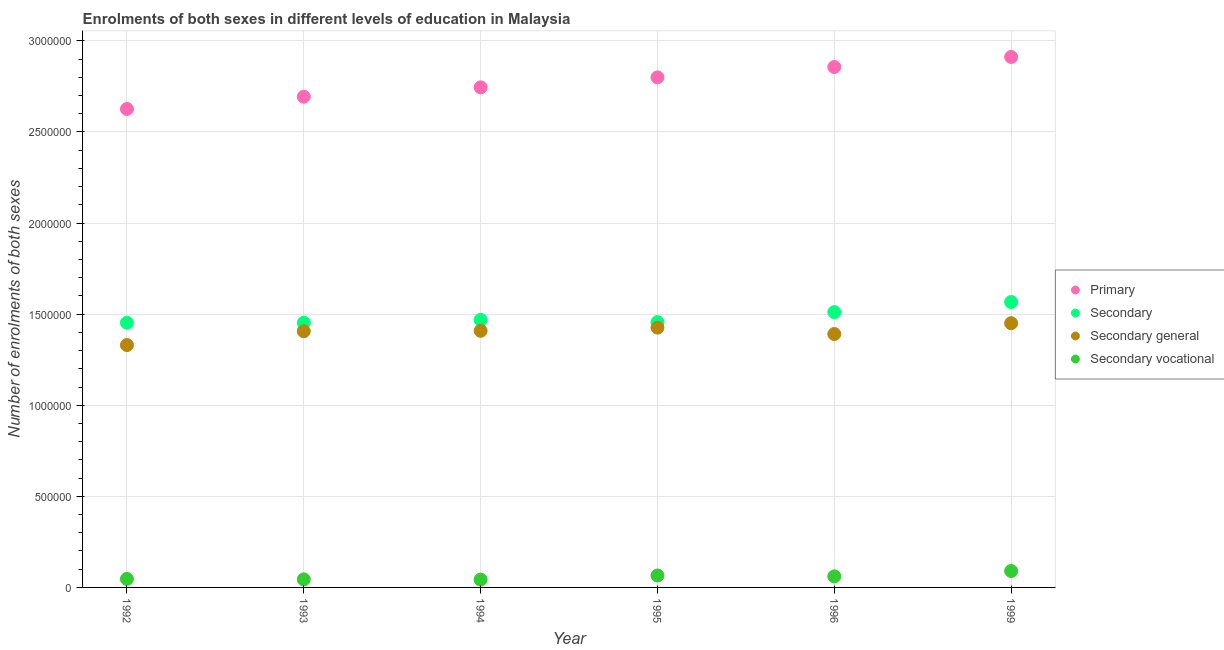Is the number of dotlines equal to the number of legend labels?
Make the answer very short. Yes. What is the number of enrolments in secondary vocational education in 1994?
Your response must be concise. 4.29e+04. Across all years, what is the maximum number of enrolments in primary education?
Make the answer very short. 2.91e+06. Across all years, what is the minimum number of enrolments in secondary general education?
Provide a short and direct response. 1.33e+06. In which year was the number of enrolments in primary education maximum?
Provide a succinct answer. 1999. What is the total number of enrolments in secondary vocational education in the graph?
Provide a succinct answer. 3.50e+05. What is the difference between the number of enrolments in primary education in 1994 and that in 1996?
Make the answer very short. -1.12e+05. What is the difference between the number of enrolments in secondary general education in 1994 and the number of enrolments in secondary vocational education in 1992?
Give a very brief answer. 1.36e+06. What is the average number of enrolments in secondary education per year?
Give a very brief answer. 1.48e+06. In the year 1999, what is the difference between the number of enrolments in secondary vocational education and number of enrolments in secondary education?
Keep it short and to the point. -1.48e+06. In how many years, is the number of enrolments in secondary education greater than 1600000?
Your answer should be very brief. 0. What is the ratio of the number of enrolments in secondary vocational education in 1992 to that in 1999?
Provide a succinct answer. 0.52. Is the number of enrolments in secondary general education in 1992 less than that in 1995?
Your answer should be very brief. Yes. Is the difference between the number of enrolments in secondary general education in 1992 and 1996 greater than the difference between the number of enrolments in secondary vocational education in 1992 and 1996?
Your answer should be compact. No. What is the difference between the highest and the second highest number of enrolments in primary education?
Offer a very short reply. 5.52e+04. What is the difference between the highest and the lowest number of enrolments in primary education?
Give a very brief answer. 2.85e+05. Is it the case that in every year, the sum of the number of enrolments in primary education and number of enrolments in secondary education is greater than the number of enrolments in secondary general education?
Your answer should be compact. Yes. What is the difference between two consecutive major ticks on the Y-axis?
Keep it short and to the point. 5.00e+05. Are the values on the major ticks of Y-axis written in scientific E-notation?
Keep it short and to the point. No. Does the graph contain grids?
Offer a terse response. Yes. What is the title of the graph?
Your response must be concise. Enrolments of both sexes in different levels of education in Malaysia. What is the label or title of the X-axis?
Make the answer very short. Year. What is the label or title of the Y-axis?
Offer a terse response. Number of enrolments of both sexes. What is the Number of enrolments of both sexes of Primary in 1992?
Offer a very short reply. 2.63e+06. What is the Number of enrolments of both sexes of Secondary in 1992?
Ensure brevity in your answer.  1.45e+06. What is the Number of enrolments of both sexes of Secondary general in 1992?
Provide a succinct answer. 1.33e+06. What is the Number of enrolments of both sexes in Secondary vocational in 1992?
Ensure brevity in your answer.  4.67e+04. What is the Number of enrolments of both sexes in Primary in 1993?
Your answer should be very brief. 2.69e+06. What is the Number of enrolments of both sexes in Secondary in 1993?
Provide a short and direct response. 1.45e+06. What is the Number of enrolments of both sexes of Secondary general in 1993?
Offer a terse response. 1.41e+06. What is the Number of enrolments of both sexes in Secondary vocational in 1993?
Keep it short and to the point. 4.43e+04. What is the Number of enrolments of both sexes in Primary in 1994?
Your response must be concise. 2.74e+06. What is the Number of enrolments of both sexes in Secondary in 1994?
Your answer should be compact. 1.47e+06. What is the Number of enrolments of both sexes in Secondary general in 1994?
Your response must be concise. 1.41e+06. What is the Number of enrolments of both sexes in Secondary vocational in 1994?
Give a very brief answer. 4.29e+04. What is the Number of enrolments of both sexes in Primary in 1995?
Give a very brief answer. 2.80e+06. What is the Number of enrolments of both sexes of Secondary in 1995?
Give a very brief answer. 1.46e+06. What is the Number of enrolments of both sexes in Secondary general in 1995?
Your answer should be very brief. 1.43e+06. What is the Number of enrolments of both sexes of Secondary vocational in 1995?
Your response must be concise. 6.55e+04. What is the Number of enrolments of both sexes of Primary in 1996?
Offer a very short reply. 2.86e+06. What is the Number of enrolments of both sexes of Secondary in 1996?
Give a very brief answer. 1.51e+06. What is the Number of enrolments of both sexes of Secondary general in 1996?
Ensure brevity in your answer.  1.39e+06. What is the Number of enrolments of both sexes in Secondary vocational in 1996?
Keep it short and to the point. 6.08e+04. What is the Number of enrolments of both sexes of Primary in 1999?
Make the answer very short. 2.91e+06. What is the Number of enrolments of both sexes of Secondary in 1999?
Provide a short and direct response. 1.57e+06. What is the Number of enrolments of both sexes of Secondary general in 1999?
Provide a short and direct response. 1.45e+06. What is the Number of enrolments of both sexes in Secondary vocational in 1999?
Provide a succinct answer. 9.01e+04. Across all years, what is the maximum Number of enrolments of both sexes of Primary?
Your response must be concise. 2.91e+06. Across all years, what is the maximum Number of enrolments of both sexes of Secondary?
Ensure brevity in your answer.  1.57e+06. Across all years, what is the maximum Number of enrolments of both sexes in Secondary general?
Provide a succinct answer. 1.45e+06. Across all years, what is the maximum Number of enrolments of both sexes in Secondary vocational?
Keep it short and to the point. 9.01e+04. Across all years, what is the minimum Number of enrolments of both sexes in Primary?
Provide a succinct answer. 2.63e+06. Across all years, what is the minimum Number of enrolments of both sexes in Secondary?
Ensure brevity in your answer.  1.45e+06. Across all years, what is the minimum Number of enrolments of both sexes of Secondary general?
Your answer should be compact. 1.33e+06. Across all years, what is the minimum Number of enrolments of both sexes of Secondary vocational?
Give a very brief answer. 4.29e+04. What is the total Number of enrolments of both sexes in Primary in the graph?
Provide a short and direct response. 1.66e+07. What is the total Number of enrolments of both sexes of Secondary in the graph?
Make the answer very short. 8.91e+06. What is the total Number of enrolments of both sexes of Secondary general in the graph?
Ensure brevity in your answer.  8.41e+06. What is the total Number of enrolments of both sexes in Secondary vocational in the graph?
Offer a terse response. 3.50e+05. What is the difference between the Number of enrolments of both sexes of Primary in 1992 and that in 1993?
Ensure brevity in your answer.  -6.73e+04. What is the difference between the Number of enrolments of both sexes in Secondary in 1992 and that in 1993?
Provide a succinct answer. -42. What is the difference between the Number of enrolments of both sexes of Secondary general in 1992 and that in 1993?
Your response must be concise. -7.59e+04. What is the difference between the Number of enrolments of both sexes of Secondary vocational in 1992 and that in 1993?
Your response must be concise. 2404. What is the difference between the Number of enrolments of both sexes of Primary in 1992 and that in 1994?
Make the answer very short. -1.19e+05. What is the difference between the Number of enrolments of both sexes in Secondary in 1992 and that in 1994?
Your answer should be compact. -1.59e+04. What is the difference between the Number of enrolments of both sexes of Secondary general in 1992 and that in 1994?
Provide a succinct answer. -7.83e+04. What is the difference between the Number of enrolments of both sexes of Secondary vocational in 1992 and that in 1994?
Make the answer very short. 3797. What is the difference between the Number of enrolments of both sexes in Primary in 1992 and that in 1995?
Make the answer very short. -1.73e+05. What is the difference between the Number of enrolments of both sexes in Secondary in 1992 and that in 1995?
Keep it short and to the point. -3573. What is the difference between the Number of enrolments of both sexes of Secondary general in 1992 and that in 1995?
Your answer should be compact. -9.56e+04. What is the difference between the Number of enrolments of both sexes in Secondary vocational in 1992 and that in 1995?
Provide a short and direct response. -1.88e+04. What is the difference between the Number of enrolments of both sexes in Primary in 1992 and that in 1996?
Your answer should be compact. -2.30e+05. What is the difference between the Number of enrolments of both sexes of Secondary in 1992 and that in 1996?
Your answer should be very brief. -5.82e+04. What is the difference between the Number of enrolments of both sexes in Secondary general in 1992 and that in 1996?
Offer a terse response. -6.07e+04. What is the difference between the Number of enrolments of both sexes in Secondary vocational in 1992 and that in 1996?
Your answer should be compact. -1.41e+04. What is the difference between the Number of enrolments of both sexes of Primary in 1992 and that in 1999?
Provide a short and direct response. -2.85e+05. What is the difference between the Number of enrolments of both sexes in Secondary in 1992 and that in 1999?
Provide a short and direct response. -1.14e+05. What is the difference between the Number of enrolments of both sexes of Secondary general in 1992 and that in 1999?
Your response must be concise. -1.20e+05. What is the difference between the Number of enrolments of both sexes of Secondary vocational in 1992 and that in 1999?
Provide a succinct answer. -4.34e+04. What is the difference between the Number of enrolments of both sexes in Primary in 1993 and that in 1994?
Provide a short and direct response. -5.14e+04. What is the difference between the Number of enrolments of both sexes of Secondary in 1993 and that in 1994?
Keep it short and to the point. -1.59e+04. What is the difference between the Number of enrolments of both sexes in Secondary general in 1993 and that in 1994?
Provide a succinct answer. -2446. What is the difference between the Number of enrolments of both sexes in Secondary vocational in 1993 and that in 1994?
Make the answer very short. 1393. What is the difference between the Number of enrolments of both sexes in Primary in 1993 and that in 1995?
Make the answer very short. -1.06e+05. What is the difference between the Number of enrolments of both sexes of Secondary in 1993 and that in 1995?
Provide a succinct answer. -3531. What is the difference between the Number of enrolments of both sexes of Secondary general in 1993 and that in 1995?
Your answer should be compact. -1.97e+04. What is the difference between the Number of enrolments of both sexes in Secondary vocational in 1993 and that in 1995?
Make the answer very short. -2.12e+04. What is the difference between the Number of enrolments of both sexes in Primary in 1993 and that in 1996?
Offer a terse response. -1.63e+05. What is the difference between the Number of enrolments of both sexes of Secondary in 1993 and that in 1996?
Offer a very short reply. -5.81e+04. What is the difference between the Number of enrolments of both sexes in Secondary general in 1993 and that in 1996?
Keep it short and to the point. 1.52e+04. What is the difference between the Number of enrolments of both sexes of Secondary vocational in 1993 and that in 1996?
Make the answer very short. -1.65e+04. What is the difference between the Number of enrolments of both sexes of Primary in 1993 and that in 1999?
Provide a succinct answer. -2.18e+05. What is the difference between the Number of enrolments of both sexes in Secondary in 1993 and that in 1999?
Provide a succinct answer. -1.14e+05. What is the difference between the Number of enrolments of both sexes in Secondary general in 1993 and that in 1999?
Your answer should be compact. -4.41e+04. What is the difference between the Number of enrolments of both sexes of Secondary vocational in 1993 and that in 1999?
Give a very brief answer. -4.58e+04. What is the difference between the Number of enrolments of both sexes of Primary in 1994 and that in 1995?
Your answer should be compact. -5.48e+04. What is the difference between the Number of enrolments of both sexes of Secondary in 1994 and that in 1995?
Your answer should be compact. 1.23e+04. What is the difference between the Number of enrolments of both sexes in Secondary general in 1994 and that in 1995?
Offer a very short reply. -1.73e+04. What is the difference between the Number of enrolments of both sexes in Secondary vocational in 1994 and that in 1995?
Your response must be concise. -2.26e+04. What is the difference between the Number of enrolments of both sexes in Primary in 1994 and that in 1996?
Your response must be concise. -1.12e+05. What is the difference between the Number of enrolments of both sexes in Secondary in 1994 and that in 1996?
Offer a terse response. -4.23e+04. What is the difference between the Number of enrolments of both sexes of Secondary general in 1994 and that in 1996?
Offer a very short reply. 1.76e+04. What is the difference between the Number of enrolments of both sexes of Secondary vocational in 1994 and that in 1996?
Provide a succinct answer. -1.79e+04. What is the difference between the Number of enrolments of both sexes of Primary in 1994 and that in 1999?
Keep it short and to the point. -1.67e+05. What is the difference between the Number of enrolments of both sexes in Secondary in 1994 and that in 1999?
Provide a short and direct response. -9.80e+04. What is the difference between the Number of enrolments of both sexes of Secondary general in 1994 and that in 1999?
Offer a terse response. -4.16e+04. What is the difference between the Number of enrolments of both sexes of Secondary vocational in 1994 and that in 1999?
Offer a very short reply. -4.72e+04. What is the difference between the Number of enrolments of both sexes in Primary in 1995 and that in 1996?
Offer a very short reply. -5.69e+04. What is the difference between the Number of enrolments of both sexes in Secondary in 1995 and that in 1996?
Keep it short and to the point. -5.46e+04. What is the difference between the Number of enrolments of both sexes in Secondary general in 1995 and that in 1996?
Ensure brevity in your answer.  3.49e+04. What is the difference between the Number of enrolments of both sexes of Secondary vocational in 1995 and that in 1996?
Ensure brevity in your answer.  4687. What is the difference between the Number of enrolments of both sexes of Primary in 1995 and that in 1999?
Ensure brevity in your answer.  -1.12e+05. What is the difference between the Number of enrolments of both sexes of Secondary in 1995 and that in 1999?
Offer a terse response. -1.10e+05. What is the difference between the Number of enrolments of both sexes in Secondary general in 1995 and that in 1999?
Ensure brevity in your answer.  -2.44e+04. What is the difference between the Number of enrolments of both sexes in Secondary vocational in 1995 and that in 1999?
Keep it short and to the point. -2.46e+04. What is the difference between the Number of enrolments of both sexes in Primary in 1996 and that in 1999?
Ensure brevity in your answer.  -5.52e+04. What is the difference between the Number of enrolments of both sexes in Secondary in 1996 and that in 1999?
Your response must be concise. -5.57e+04. What is the difference between the Number of enrolments of both sexes of Secondary general in 1996 and that in 1999?
Your answer should be very brief. -5.93e+04. What is the difference between the Number of enrolments of both sexes of Secondary vocational in 1996 and that in 1999?
Offer a terse response. -2.93e+04. What is the difference between the Number of enrolments of both sexes in Primary in 1992 and the Number of enrolments of both sexes in Secondary in 1993?
Your answer should be very brief. 1.17e+06. What is the difference between the Number of enrolments of both sexes of Primary in 1992 and the Number of enrolments of both sexes of Secondary general in 1993?
Provide a succinct answer. 1.22e+06. What is the difference between the Number of enrolments of both sexes of Primary in 1992 and the Number of enrolments of both sexes of Secondary vocational in 1993?
Provide a short and direct response. 2.58e+06. What is the difference between the Number of enrolments of both sexes in Secondary in 1992 and the Number of enrolments of both sexes in Secondary general in 1993?
Your response must be concise. 4.67e+04. What is the difference between the Number of enrolments of both sexes in Secondary in 1992 and the Number of enrolments of both sexes in Secondary vocational in 1993?
Your answer should be compact. 1.41e+06. What is the difference between the Number of enrolments of both sexes of Secondary general in 1992 and the Number of enrolments of both sexes of Secondary vocational in 1993?
Your answer should be compact. 1.29e+06. What is the difference between the Number of enrolments of both sexes in Primary in 1992 and the Number of enrolments of both sexes in Secondary in 1994?
Your answer should be very brief. 1.16e+06. What is the difference between the Number of enrolments of both sexes of Primary in 1992 and the Number of enrolments of both sexes of Secondary general in 1994?
Offer a very short reply. 1.22e+06. What is the difference between the Number of enrolments of both sexes in Primary in 1992 and the Number of enrolments of both sexes in Secondary vocational in 1994?
Keep it short and to the point. 2.58e+06. What is the difference between the Number of enrolments of both sexes of Secondary in 1992 and the Number of enrolments of both sexes of Secondary general in 1994?
Your response must be concise. 4.43e+04. What is the difference between the Number of enrolments of both sexes of Secondary in 1992 and the Number of enrolments of both sexes of Secondary vocational in 1994?
Provide a short and direct response. 1.41e+06. What is the difference between the Number of enrolments of both sexes in Secondary general in 1992 and the Number of enrolments of both sexes in Secondary vocational in 1994?
Make the answer very short. 1.29e+06. What is the difference between the Number of enrolments of both sexes of Primary in 1992 and the Number of enrolments of both sexes of Secondary in 1995?
Give a very brief answer. 1.17e+06. What is the difference between the Number of enrolments of both sexes of Primary in 1992 and the Number of enrolments of both sexes of Secondary general in 1995?
Your answer should be very brief. 1.20e+06. What is the difference between the Number of enrolments of both sexes in Primary in 1992 and the Number of enrolments of both sexes in Secondary vocational in 1995?
Your answer should be very brief. 2.56e+06. What is the difference between the Number of enrolments of both sexes in Secondary in 1992 and the Number of enrolments of both sexes in Secondary general in 1995?
Keep it short and to the point. 2.70e+04. What is the difference between the Number of enrolments of both sexes in Secondary in 1992 and the Number of enrolments of both sexes in Secondary vocational in 1995?
Provide a succinct answer. 1.39e+06. What is the difference between the Number of enrolments of both sexes in Secondary general in 1992 and the Number of enrolments of both sexes in Secondary vocational in 1995?
Keep it short and to the point. 1.26e+06. What is the difference between the Number of enrolments of both sexes of Primary in 1992 and the Number of enrolments of both sexes of Secondary in 1996?
Offer a very short reply. 1.12e+06. What is the difference between the Number of enrolments of both sexes in Primary in 1992 and the Number of enrolments of both sexes in Secondary general in 1996?
Provide a short and direct response. 1.24e+06. What is the difference between the Number of enrolments of both sexes of Primary in 1992 and the Number of enrolments of both sexes of Secondary vocational in 1996?
Your response must be concise. 2.57e+06. What is the difference between the Number of enrolments of both sexes of Secondary in 1992 and the Number of enrolments of both sexes of Secondary general in 1996?
Your answer should be very brief. 6.19e+04. What is the difference between the Number of enrolments of both sexes of Secondary in 1992 and the Number of enrolments of both sexes of Secondary vocational in 1996?
Offer a very short reply. 1.39e+06. What is the difference between the Number of enrolments of both sexes of Secondary general in 1992 and the Number of enrolments of both sexes of Secondary vocational in 1996?
Your response must be concise. 1.27e+06. What is the difference between the Number of enrolments of both sexes in Primary in 1992 and the Number of enrolments of both sexes in Secondary in 1999?
Provide a succinct answer. 1.06e+06. What is the difference between the Number of enrolments of both sexes of Primary in 1992 and the Number of enrolments of both sexes of Secondary general in 1999?
Your answer should be very brief. 1.18e+06. What is the difference between the Number of enrolments of both sexes in Primary in 1992 and the Number of enrolments of both sexes in Secondary vocational in 1999?
Give a very brief answer. 2.54e+06. What is the difference between the Number of enrolments of both sexes of Secondary in 1992 and the Number of enrolments of both sexes of Secondary general in 1999?
Make the answer very short. 2613. What is the difference between the Number of enrolments of both sexes in Secondary in 1992 and the Number of enrolments of both sexes in Secondary vocational in 1999?
Your answer should be compact. 1.36e+06. What is the difference between the Number of enrolments of both sexes of Secondary general in 1992 and the Number of enrolments of both sexes of Secondary vocational in 1999?
Offer a very short reply. 1.24e+06. What is the difference between the Number of enrolments of both sexes in Primary in 1993 and the Number of enrolments of both sexes in Secondary in 1994?
Keep it short and to the point. 1.22e+06. What is the difference between the Number of enrolments of both sexes of Primary in 1993 and the Number of enrolments of both sexes of Secondary general in 1994?
Offer a terse response. 1.28e+06. What is the difference between the Number of enrolments of both sexes of Primary in 1993 and the Number of enrolments of both sexes of Secondary vocational in 1994?
Your response must be concise. 2.65e+06. What is the difference between the Number of enrolments of both sexes of Secondary in 1993 and the Number of enrolments of both sexes of Secondary general in 1994?
Ensure brevity in your answer.  4.43e+04. What is the difference between the Number of enrolments of both sexes of Secondary in 1993 and the Number of enrolments of both sexes of Secondary vocational in 1994?
Your answer should be very brief. 1.41e+06. What is the difference between the Number of enrolments of both sexes of Secondary general in 1993 and the Number of enrolments of both sexes of Secondary vocational in 1994?
Give a very brief answer. 1.36e+06. What is the difference between the Number of enrolments of both sexes in Primary in 1993 and the Number of enrolments of both sexes in Secondary in 1995?
Give a very brief answer. 1.24e+06. What is the difference between the Number of enrolments of both sexes of Primary in 1993 and the Number of enrolments of both sexes of Secondary general in 1995?
Make the answer very short. 1.27e+06. What is the difference between the Number of enrolments of both sexes in Primary in 1993 and the Number of enrolments of both sexes in Secondary vocational in 1995?
Offer a terse response. 2.63e+06. What is the difference between the Number of enrolments of both sexes of Secondary in 1993 and the Number of enrolments of both sexes of Secondary general in 1995?
Your response must be concise. 2.70e+04. What is the difference between the Number of enrolments of both sexes in Secondary in 1993 and the Number of enrolments of both sexes in Secondary vocational in 1995?
Your answer should be compact. 1.39e+06. What is the difference between the Number of enrolments of both sexes of Secondary general in 1993 and the Number of enrolments of both sexes of Secondary vocational in 1995?
Provide a succinct answer. 1.34e+06. What is the difference between the Number of enrolments of both sexes of Primary in 1993 and the Number of enrolments of both sexes of Secondary in 1996?
Your answer should be compact. 1.18e+06. What is the difference between the Number of enrolments of both sexes in Primary in 1993 and the Number of enrolments of both sexes in Secondary general in 1996?
Your response must be concise. 1.30e+06. What is the difference between the Number of enrolments of both sexes of Primary in 1993 and the Number of enrolments of both sexes of Secondary vocational in 1996?
Your answer should be very brief. 2.63e+06. What is the difference between the Number of enrolments of both sexes in Secondary in 1993 and the Number of enrolments of both sexes in Secondary general in 1996?
Your answer should be compact. 6.19e+04. What is the difference between the Number of enrolments of both sexes of Secondary in 1993 and the Number of enrolments of both sexes of Secondary vocational in 1996?
Ensure brevity in your answer.  1.39e+06. What is the difference between the Number of enrolments of both sexes of Secondary general in 1993 and the Number of enrolments of both sexes of Secondary vocational in 1996?
Offer a very short reply. 1.35e+06. What is the difference between the Number of enrolments of both sexes of Primary in 1993 and the Number of enrolments of both sexes of Secondary in 1999?
Your answer should be very brief. 1.13e+06. What is the difference between the Number of enrolments of both sexes of Primary in 1993 and the Number of enrolments of both sexes of Secondary general in 1999?
Offer a terse response. 1.24e+06. What is the difference between the Number of enrolments of both sexes in Primary in 1993 and the Number of enrolments of both sexes in Secondary vocational in 1999?
Your answer should be compact. 2.60e+06. What is the difference between the Number of enrolments of both sexes in Secondary in 1993 and the Number of enrolments of both sexes in Secondary general in 1999?
Give a very brief answer. 2655. What is the difference between the Number of enrolments of both sexes of Secondary in 1993 and the Number of enrolments of both sexes of Secondary vocational in 1999?
Provide a succinct answer. 1.36e+06. What is the difference between the Number of enrolments of both sexes of Secondary general in 1993 and the Number of enrolments of both sexes of Secondary vocational in 1999?
Give a very brief answer. 1.32e+06. What is the difference between the Number of enrolments of both sexes in Primary in 1994 and the Number of enrolments of both sexes in Secondary in 1995?
Your answer should be compact. 1.29e+06. What is the difference between the Number of enrolments of both sexes of Primary in 1994 and the Number of enrolments of both sexes of Secondary general in 1995?
Give a very brief answer. 1.32e+06. What is the difference between the Number of enrolments of both sexes of Primary in 1994 and the Number of enrolments of both sexes of Secondary vocational in 1995?
Provide a succinct answer. 2.68e+06. What is the difference between the Number of enrolments of both sexes of Secondary in 1994 and the Number of enrolments of both sexes of Secondary general in 1995?
Your answer should be very brief. 4.29e+04. What is the difference between the Number of enrolments of both sexes of Secondary in 1994 and the Number of enrolments of both sexes of Secondary vocational in 1995?
Provide a short and direct response. 1.40e+06. What is the difference between the Number of enrolments of both sexes in Secondary general in 1994 and the Number of enrolments of both sexes in Secondary vocational in 1995?
Make the answer very short. 1.34e+06. What is the difference between the Number of enrolments of both sexes of Primary in 1994 and the Number of enrolments of both sexes of Secondary in 1996?
Provide a succinct answer. 1.23e+06. What is the difference between the Number of enrolments of both sexes of Primary in 1994 and the Number of enrolments of both sexes of Secondary general in 1996?
Your answer should be compact. 1.35e+06. What is the difference between the Number of enrolments of both sexes of Primary in 1994 and the Number of enrolments of both sexes of Secondary vocational in 1996?
Make the answer very short. 2.68e+06. What is the difference between the Number of enrolments of both sexes of Secondary in 1994 and the Number of enrolments of both sexes of Secondary general in 1996?
Your answer should be very brief. 7.78e+04. What is the difference between the Number of enrolments of both sexes of Secondary in 1994 and the Number of enrolments of both sexes of Secondary vocational in 1996?
Give a very brief answer. 1.41e+06. What is the difference between the Number of enrolments of both sexes of Secondary general in 1994 and the Number of enrolments of both sexes of Secondary vocational in 1996?
Ensure brevity in your answer.  1.35e+06. What is the difference between the Number of enrolments of both sexes of Primary in 1994 and the Number of enrolments of both sexes of Secondary in 1999?
Offer a terse response. 1.18e+06. What is the difference between the Number of enrolments of both sexes in Primary in 1994 and the Number of enrolments of both sexes in Secondary general in 1999?
Give a very brief answer. 1.29e+06. What is the difference between the Number of enrolments of both sexes in Primary in 1994 and the Number of enrolments of both sexes in Secondary vocational in 1999?
Offer a very short reply. 2.65e+06. What is the difference between the Number of enrolments of both sexes of Secondary in 1994 and the Number of enrolments of both sexes of Secondary general in 1999?
Keep it short and to the point. 1.85e+04. What is the difference between the Number of enrolments of both sexes of Secondary in 1994 and the Number of enrolments of both sexes of Secondary vocational in 1999?
Provide a short and direct response. 1.38e+06. What is the difference between the Number of enrolments of both sexes in Secondary general in 1994 and the Number of enrolments of both sexes in Secondary vocational in 1999?
Provide a short and direct response. 1.32e+06. What is the difference between the Number of enrolments of both sexes in Primary in 1995 and the Number of enrolments of both sexes in Secondary in 1996?
Provide a short and direct response. 1.29e+06. What is the difference between the Number of enrolments of both sexes in Primary in 1995 and the Number of enrolments of both sexes in Secondary general in 1996?
Ensure brevity in your answer.  1.41e+06. What is the difference between the Number of enrolments of both sexes of Primary in 1995 and the Number of enrolments of both sexes of Secondary vocational in 1996?
Give a very brief answer. 2.74e+06. What is the difference between the Number of enrolments of both sexes in Secondary in 1995 and the Number of enrolments of both sexes in Secondary general in 1996?
Your answer should be very brief. 6.55e+04. What is the difference between the Number of enrolments of both sexes in Secondary in 1995 and the Number of enrolments of both sexes in Secondary vocational in 1996?
Offer a very short reply. 1.40e+06. What is the difference between the Number of enrolments of both sexes of Secondary general in 1995 and the Number of enrolments of both sexes of Secondary vocational in 1996?
Make the answer very short. 1.37e+06. What is the difference between the Number of enrolments of both sexes in Primary in 1995 and the Number of enrolments of both sexes in Secondary in 1999?
Give a very brief answer. 1.23e+06. What is the difference between the Number of enrolments of both sexes in Primary in 1995 and the Number of enrolments of both sexes in Secondary general in 1999?
Make the answer very short. 1.35e+06. What is the difference between the Number of enrolments of both sexes of Primary in 1995 and the Number of enrolments of both sexes of Secondary vocational in 1999?
Provide a succinct answer. 2.71e+06. What is the difference between the Number of enrolments of both sexes of Secondary in 1995 and the Number of enrolments of both sexes of Secondary general in 1999?
Your answer should be very brief. 6186. What is the difference between the Number of enrolments of both sexes in Secondary in 1995 and the Number of enrolments of both sexes in Secondary vocational in 1999?
Provide a succinct answer. 1.37e+06. What is the difference between the Number of enrolments of both sexes in Secondary general in 1995 and the Number of enrolments of both sexes in Secondary vocational in 1999?
Provide a succinct answer. 1.34e+06. What is the difference between the Number of enrolments of both sexes in Primary in 1996 and the Number of enrolments of both sexes in Secondary in 1999?
Give a very brief answer. 1.29e+06. What is the difference between the Number of enrolments of both sexes in Primary in 1996 and the Number of enrolments of both sexes in Secondary general in 1999?
Your answer should be compact. 1.41e+06. What is the difference between the Number of enrolments of both sexes of Primary in 1996 and the Number of enrolments of both sexes of Secondary vocational in 1999?
Offer a terse response. 2.77e+06. What is the difference between the Number of enrolments of both sexes of Secondary in 1996 and the Number of enrolments of both sexes of Secondary general in 1999?
Provide a short and direct response. 6.08e+04. What is the difference between the Number of enrolments of both sexes of Secondary in 1996 and the Number of enrolments of both sexes of Secondary vocational in 1999?
Make the answer very short. 1.42e+06. What is the difference between the Number of enrolments of both sexes in Secondary general in 1996 and the Number of enrolments of both sexes in Secondary vocational in 1999?
Provide a succinct answer. 1.30e+06. What is the average Number of enrolments of both sexes in Primary per year?
Offer a very short reply. 2.77e+06. What is the average Number of enrolments of both sexes of Secondary per year?
Offer a very short reply. 1.48e+06. What is the average Number of enrolments of both sexes in Secondary general per year?
Make the answer very short. 1.40e+06. What is the average Number of enrolments of both sexes of Secondary vocational per year?
Keep it short and to the point. 5.84e+04. In the year 1992, what is the difference between the Number of enrolments of both sexes of Primary and Number of enrolments of both sexes of Secondary?
Ensure brevity in your answer.  1.17e+06. In the year 1992, what is the difference between the Number of enrolments of both sexes in Primary and Number of enrolments of both sexes in Secondary general?
Keep it short and to the point. 1.30e+06. In the year 1992, what is the difference between the Number of enrolments of both sexes in Primary and Number of enrolments of both sexes in Secondary vocational?
Give a very brief answer. 2.58e+06. In the year 1992, what is the difference between the Number of enrolments of both sexes in Secondary and Number of enrolments of both sexes in Secondary general?
Provide a succinct answer. 1.23e+05. In the year 1992, what is the difference between the Number of enrolments of both sexes in Secondary and Number of enrolments of both sexes in Secondary vocational?
Your answer should be very brief. 1.41e+06. In the year 1992, what is the difference between the Number of enrolments of both sexes of Secondary general and Number of enrolments of both sexes of Secondary vocational?
Offer a terse response. 1.28e+06. In the year 1993, what is the difference between the Number of enrolments of both sexes in Primary and Number of enrolments of both sexes in Secondary?
Offer a terse response. 1.24e+06. In the year 1993, what is the difference between the Number of enrolments of both sexes of Primary and Number of enrolments of both sexes of Secondary general?
Make the answer very short. 1.29e+06. In the year 1993, what is the difference between the Number of enrolments of both sexes in Primary and Number of enrolments of both sexes in Secondary vocational?
Provide a short and direct response. 2.65e+06. In the year 1993, what is the difference between the Number of enrolments of both sexes in Secondary and Number of enrolments of both sexes in Secondary general?
Offer a terse response. 4.67e+04. In the year 1993, what is the difference between the Number of enrolments of both sexes in Secondary and Number of enrolments of both sexes in Secondary vocational?
Make the answer very short. 1.41e+06. In the year 1993, what is the difference between the Number of enrolments of both sexes in Secondary general and Number of enrolments of both sexes in Secondary vocational?
Provide a succinct answer. 1.36e+06. In the year 1994, what is the difference between the Number of enrolments of both sexes in Primary and Number of enrolments of both sexes in Secondary?
Give a very brief answer. 1.28e+06. In the year 1994, what is the difference between the Number of enrolments of both sexes of Primary and Number of enrolments of both sexes of Secondary general?
Your answer should be compact. 1.34e+06. In the year 1994, what is the difference between the Number of enrolments of both sexes in Primary and Number of enrolments of both sexes in Secondary vocational?
Your answer should be compact. 2.70e+06. In the year 1994, what is the difference between the Number of enrolments of both sexes in Secondary and Number of enrolments of both sexes in Secondary general?
Offer a very short reply. 6.02e+04. In the year 1994, what is the difference between the Number of enrolments of both sexes in Secondary and Number of enrolments of both sexes in Secondary vocational?
Offer a very short reply. 1.43e+06. In the year 1994, what is the difference between the Number of enrolments of both sexes in Secondary general and Number of enrolments of both sexes in Secondary vocational?
Your answer should be compact. 1.37e+06. In the year 1995, what is the difference between the Number of enrolments of both sexes in Primary and Number of enrolments of both sexes in Secondary?
Keep it short and to the point. 1.34e+06. In the year 1995, what is the difference between the Number of enrolments of both sexes in Primary and Number of enrolments of both sexes in Secondary general?
Your answer should be compact. 1.37e+06. In the year 1995, what is the difference between the Number of enrolments of both sexes in Primary and Number of enrolments of both sexes in Secondary vocational?
Keep it short and to the point. 2.73e+06. In the year 1995, what is the difference between the Number of enrolments of both sexes in Secondary and Number of enrolments of both sexes in Secondary general?
Your response must be concise. 3.06e+04. In the year 1995, what is the difference between the Number of enrolments of both sexes in Secondary and Number of enrolments of both sexes in Secondary vocational?
Give a very brief answer. 1.39e+06. In the year 1995, what is the difference between the Number of enrolments of both sexes in Secondary general and Number of enrolments of both sexes in Secondary vocational?
Keep it short and to the point. 1.36e+06. In the year 1996, what is the difference between the Number of enrolments of both sexes in Primary and Number of enrolments of both sexes in Secondary?
Offer a very short reply. 1.35e+06. In the year 1996, what is the difference between the Number of enrolments of both sexes of Primary and Number of enrolments of both sexes of Secondary general?
Keep it short and to the point. 1.47e+06. In the year 1996, what is the difference between the Number of enrolments of both sexes of Primary and Number of enrolments of both sexes of Secondary vocational?
Ensure brevity in your answer.  2.80e+06. In the year 1996, what is the difference between the Number of enrolments of both sexes of Secondary and Number of enrolments of both sexes of Secondary general?
Offer a terse response. 1.20e+05. In the year 1996, what is the difference between the Number of enrolments of both sexes in Secondary and Number of enrolments of both sexes in Secondary vocational?
Keep it short and to the point. 1.45e+06. In the year 1996, what is the difference between the Number of enrolments of both sexes of Secondary general and Number of enrolments of both sexes of Secondary vocational?
Offer a very short reply. 1.33e+06. In the year 1999, what is the difference between the Number of enrolments of both sexes of Primary and Number of enrolments of both sexes of Secondary?
Make the answer very short. 1.34e+06. In the year 1999, what is the difference between the Number of enrolments of both sexes of Primary and Number of enrolments of both sexes of Secondary general?
Give a very brief answer. 1.46e+06. In the year 1999, what is the difference between the Number of enrolments of both sexes in Primary and Number of enrolments of both sexes in Secondary vocational?
Keep it short and to the point. 2.82e+06. In the year 1999, what is the difference between the Number of enrolments of both sexes of Secondary and Number of enrolments of both sexes of Secondary general?
Give a very brief answer. 1.16e+05. In the year 1999, what is the difference between the Number of enrolments of both sexes of Secondary and Number of enrolments of both sexes of Secondary vocational?
Provide a short and direct response. 1.48e+06. In the year 1999, what is the difference between the Number of enrolments of both sexes of Secondary general and Number of enrolments of both sexes of Secondary vocational?
Your response must be concise. 1.36e+06. What is the ratio of the Number of enrolments of both sexes of Secondary in 1992 to that in 1993?
Make the answer very short. 1. What is the ratio of the Number of enrolments of both sexes in Secondary general in 1992 to that in 1993?
Provide a succinct answer. 0.95. What is the ratio of the Number of enrolments of both sexes in Secondary vocational in 1992 to that in 1993?
Provide a succinct answer. 1.05. What is the ratio of the Number of enrolments of both sexes in Primary in 1992 to that in 1994?
Your answer should be compact. 0.96. What is the ratio of the Number of enrolments of both sexes in Secondary in 1992 to that in 1994?
Ensure brevity in your answer.  0.99. What is the ratio of the Number of enrolments of both sexes in Secondary general in 1992 to that in 1994?
Your response must be concise. 0.94. What is the ratio of the Number of enrolments of both sexes of Secondary vocational in 1992 to that in 1994?
Your answer should be compact. 1.09. What is the ratio of the Number of enrolments of both sexes of Primary in 1992 to that in 1995?
Your response must be concise. 0.94. What is the ratio of the Number of enrolments of both sexes of Secondary in 1992 to that in 1995?
Your answer should be very brief. 1. What is the ratio of the Number of enrolments of both sexes of Secondary general in 1992 to that in 1995?
Make the answer very short. 0.93. What is the ratio of the Number of enrolments of both sexes in Secondary vocational in 1992 to that in 1995?
Make the answer very short. 0.71. What is the ratio of the Number of enrolments of both sexes of Primary in 1992 to that in 1996?
Your response must be concise. 0.92. What is the ratio of the Number of enrolments of both sexes of Secondary in 1992 to that in 1996?
Offer a very short reply. 0.96. What is the ratio of the Number of enrolments of both sexes of Secondary general in 1992 to that in 1996?
Keep it short and to the point. 0.96. What is the ratio of the Number of enrolments of both sexes in Secondary vocational in 1992 to that in 1996?
Give a very brief answer. 0.77. What is the ratio of the Number of enrolments of both sexes of Primary in 1992 to that in 1999?
Give a very brief answer. 0.9. What is the ratio of the Number of enrolments of both sexes in Secondary in 1992 to that in 1999?
Give a very brief answer. 0.93. What is the ratio of the Number of enrolments of both sexes in Secondary general in 1992 to that in 1999?
Provide a succinct answer. 0.92. What is the ratio of the Number of enrolments of both sexes of Secondary vocational in 1992 to that in 1999?
Keep it short and to the point. 0.52. What is the ratio of the Number of enrolments of both sexes in Primary in 1993 to that in 1994?
Provide a succinct answer. 0.98. What is the ratio of the Number of enrolments of both sexes of Secondary in 1993 to that in 1994?
Keep it short and to the point. 0.99. What is the ratio of the Number of enrolments of both sexes of Secondary general in 1993 to that in 1994?
Your response must be concise. 1. What is the ratio of the Number of enrolments of both sexes of Secondary vocational in 1993 to that in 1994?
Offer a very short reply. 1.03. What is the ratio of the Number of enrolments of both sexes of Primary in 1993 to that in 1995?
Make the answer very short. 0.96. What is the ratio of the Number of enrolments of both sexes in Secondary general in 1993 to that in 1995?
Keep it short and to the point. 0.99. What is the ratio of the Number of enrolments of both sexes of Secondary vocational in 1993 to that in 1995?
Offer a very short reply. 0.68. What is the ratio of the Number of enrolments of both sexes of Primary in 1993 to that in 1996?
Give a very brief answer. 0.94. What is the ratio of the Number of enrolments of both sexes in Secondary in 1993 to that in 1996?
Offer a very short reply. 0.96. What is the ratio of the Number of enrolments of both sexes of Secondary general in 1993 to that in 1996?
Keep it short and to the point. 1.01. What is the ratio of the Number of enrolments of both sexes in Secondary vocational in 1993 to that in 1996?
Provide a succinct answer. 0.73. What is the ratio of the Number of enrolments of both sexes of Primary in 1993 to that in 1999?
Make the answer very short. 0.93. What is the ratio of the Number of enrolments of both sexes of Secondary in 1993 to that in 1999?
Provide a succinct answer. 0.93. What is the ratio of the Number of enrolments of both sexes of Secondary general in 1993 to that in 1999?
Provide a short and direct response. 0.97. What is the ratio of the Number of enrolments of both sexes in Secondary vocational in 1993 to that in 1999?
Your answer should be very brief. 0.49. What is the ratio of the Number of enrolments of both sexes in Primary in 1994 to that in 1995?
Your answer should be compact. 0.98. What is the ratio of the Number of enrolments of both sexes of Secondary in 1994 to that in 1995?
Keep it short and to the point. 1.01. What is the ratio of the Number of enrolments of both sexes of Secondary general in 1994 to that in 1995?
Your answer should be very brief. 0.99. What is the ratio of the Number of enrolments of both sexes in Secondary vocational in 1994 to that in 1995?
Offer a terse response. 0.66. What is the ratio of the Number of enrolments of both sexes of Primary in 1994 to that in 1996?
Provide a succinct answer. 0.96. What is the ratio of the Number of enrolments of both sexes in Secondary in 1994 to that in 1996?
Provide a succinct answer. 0.97. What is the ratio of the Number of enrolments of both sexes of Secondary general in 1994 to that in 1996?
Your response must be concise. 1.01. What is the ratio of the Number of enrolments of both sexes in Secondary vocational in 1994 to that in 1996?
Your answer should be very brief. 0.71. What is the ratio of the Number of enrolments of both sexes in Primary in 1994 to that in 1999?
Provide a short and direct response. 0.94. What is the ratio of the Number of enrolments of both sexes in Secondary in 1994 to that in 1999?
Keep it short and to the point. 0.94. What is the ratio of the Number of enrolments of both sexes in Secondary general in 1994 to that in 1999?
Your answer should be very brief. 0.97. What is the ratio of the Number of enrolments of both sexes of Secondary vocational in 1994 to that in 1999?
Provide a short and direct response. 0.48. What is the ratio of the Number of enrolments of both sexes in Primary in 1995 to that in 1996?
Offer a terse response. 0.98. What is the ratio of the Number of enrolments of both sexes in Secondary in 1995 to that in 1996?
Provide a short and direct response. 0.96. What is the ratio of the Number of enrolments of both sexes of Secondary general in 1995 to that in 1996?
Your answer should be very brief. 1.03. What is the ratio of the Number of enrolments of both sexes in Secondary vocational in 1995 to that in 1996?
Your answer should be compact. 1.08. What is the ratio of the Number of enrolments of both sexes of Primary in 1995 to that in 1999?
Provide a succinct answer. 0.96. What is the ratio of the Number of enrolments of both sexes in Secondary in 1995 to that in 1999?
Your response must be concise. 0.93. What is the ratio of the Number of enrolments of both sexes in Secondary general in 1995 to that in 1999?
Your answer should be compact. 0.98. What is the ratio of the Number of enrolments of both sexes of Secondary vocational in 1995 to that in 1999?
Give a very brief answer. 0.73. What is the ratio of the Number of enrolments of both sexes in Primary in 1996 to that in 1999?
Make the answer very short. 0.98. What is the ratio of the Number of enrolments of both sexes of Secondary in 1996 to that in 1999?
Provide a succinct answer. 0.96. What is the ratio of the Number of enrolments of both sexes of Secondary general in 1996 to that in 1999?
Your answer should be compact. 0.96. What is the ratio of the Number of enrolments of both sexes of Secondary vocational in 1996 to that in 1999?
Your answer should be very brief. 0.67. What is the difference between the highest and the second highest Number of enrolments of both sexes in Primary?
Ensure brevity in your answer.  5.52e+04. What is the difference between the highest and the second highest Number of enrolments of both sexes of Secondary?
Your answer should be very brief. 5.57e+04. What is the difference between the highest and the second highest Number of enrolments of both sexes in Secondary general?
Your answer should be very brief. 2.44e+04. What is the difference between the highest and the second highest Number of enrolments of both sexes of Secondary vocational?
Give a very brief answer. 2.46e+04. What is the difference between the highest and the lowest Number of enrolments of both sexes of Primary?
Keep it short and to the point. 2.85e+05. What is the difference between the highest and the lowest Number of enrolments of both sexes in Secondary?
Your answer should be very brief. 1.14e+05. What is the difference between the highest and the lowest Number of enrolments of both sexes of Secondary general?
Provide a succinct answer. 1.20e+05. What is the difference between the highest and the lowest Number of enrolments of both sexes in Secondary vocational?
Provide a short and direct response. 4.72e+04. 